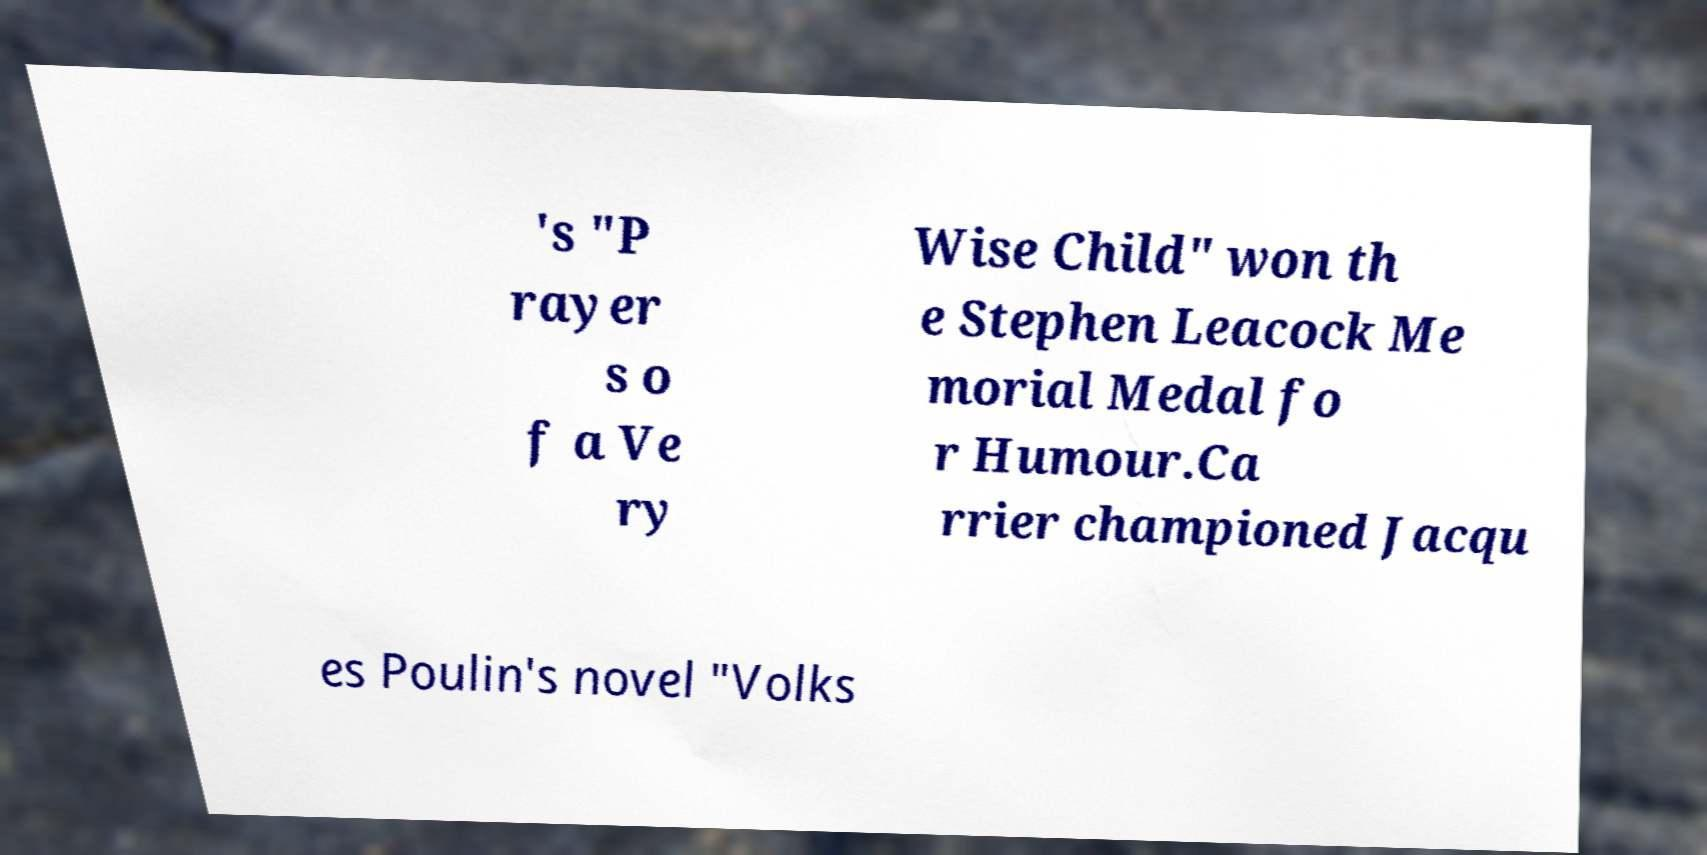There's text embedded in this image that I need extracted. Can you transcribe it verbatim? 's "P rayer s o f a Ve ry Wise Child" won th e Stephen Leacock Me morial Medal fo r Humour.Ca rrier championed Jacqu es Poulin's novel "Volks 